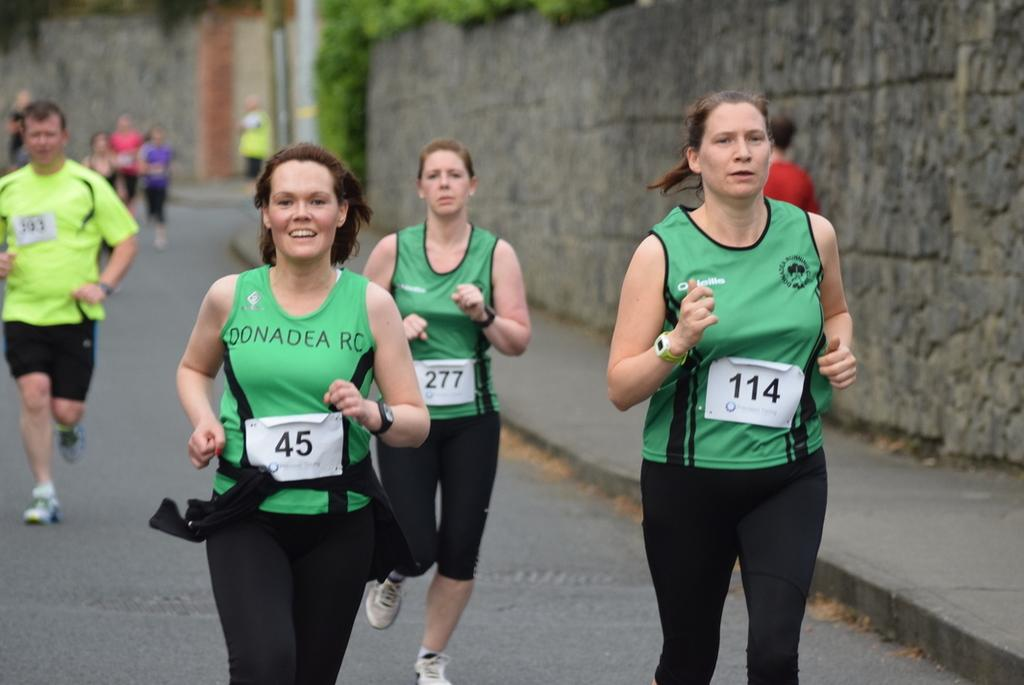Provide a one-sentence caption for the provided image. Marathoners run in the street with number 45 taking the lead. 